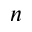<formula> <loc_0><loc_0><loc_500><loc_500>n</formula> 